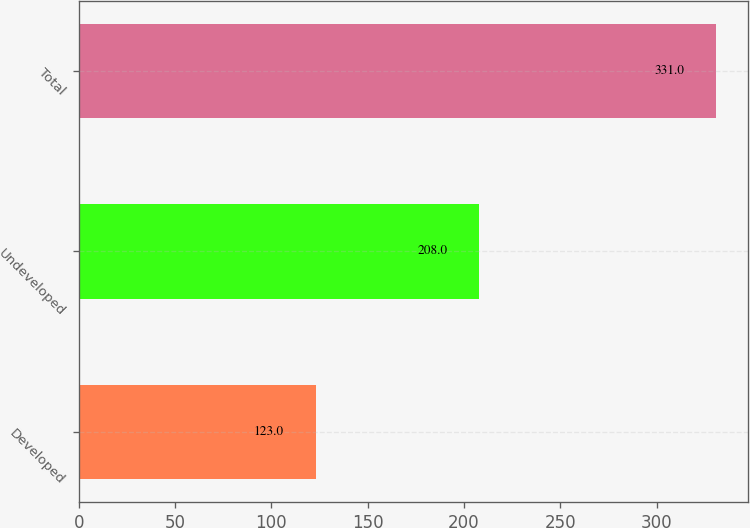Convert chart. <chart><loc_0><loc_0><loc_500><loc_500><bar_chart><fcel>Developed<fcel>Undeveloped<fcel>Total<nl><fcel>123<fcel>208<fcel>331<nl></chart> 